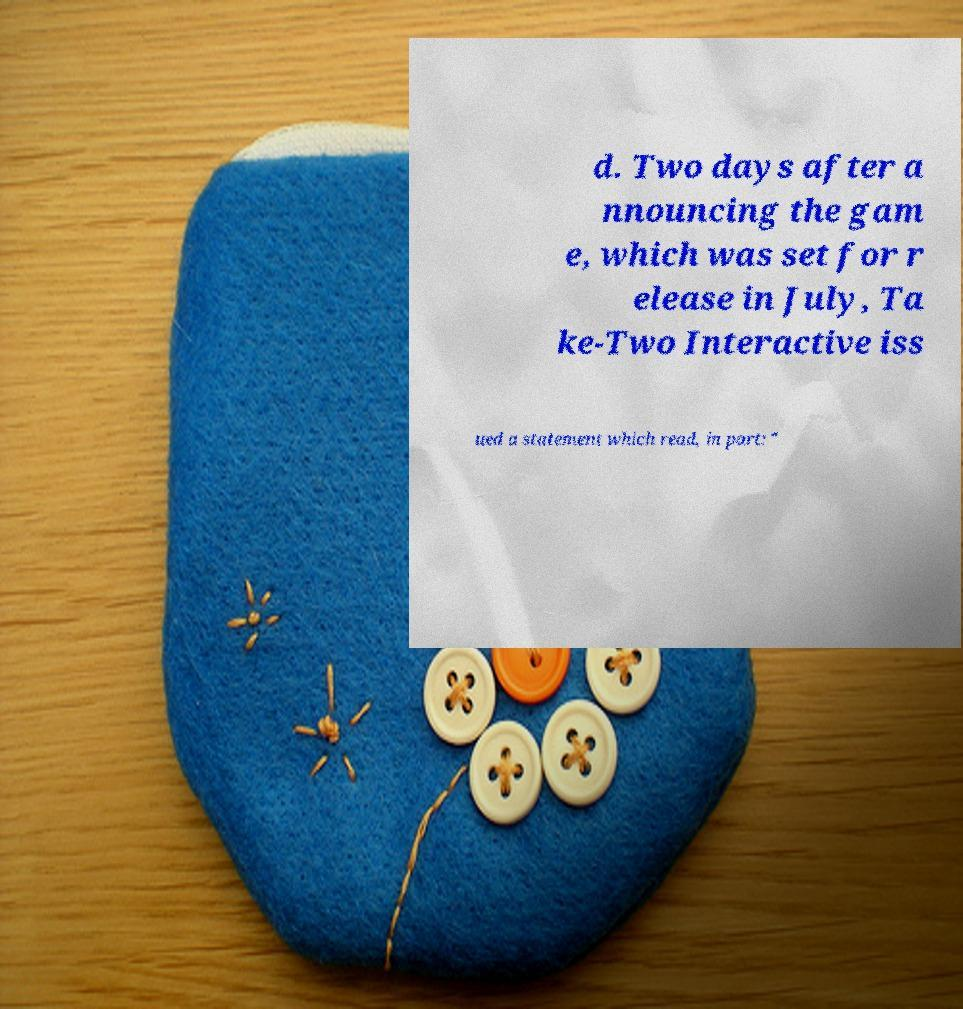What messages or text are displayed in this image? I need them in a readable, typed format. d. Two days after a nnouncing the gam e, which was set for r elease in July, Ta ke-Two Interactive iss ued a statement which read, in part: " 